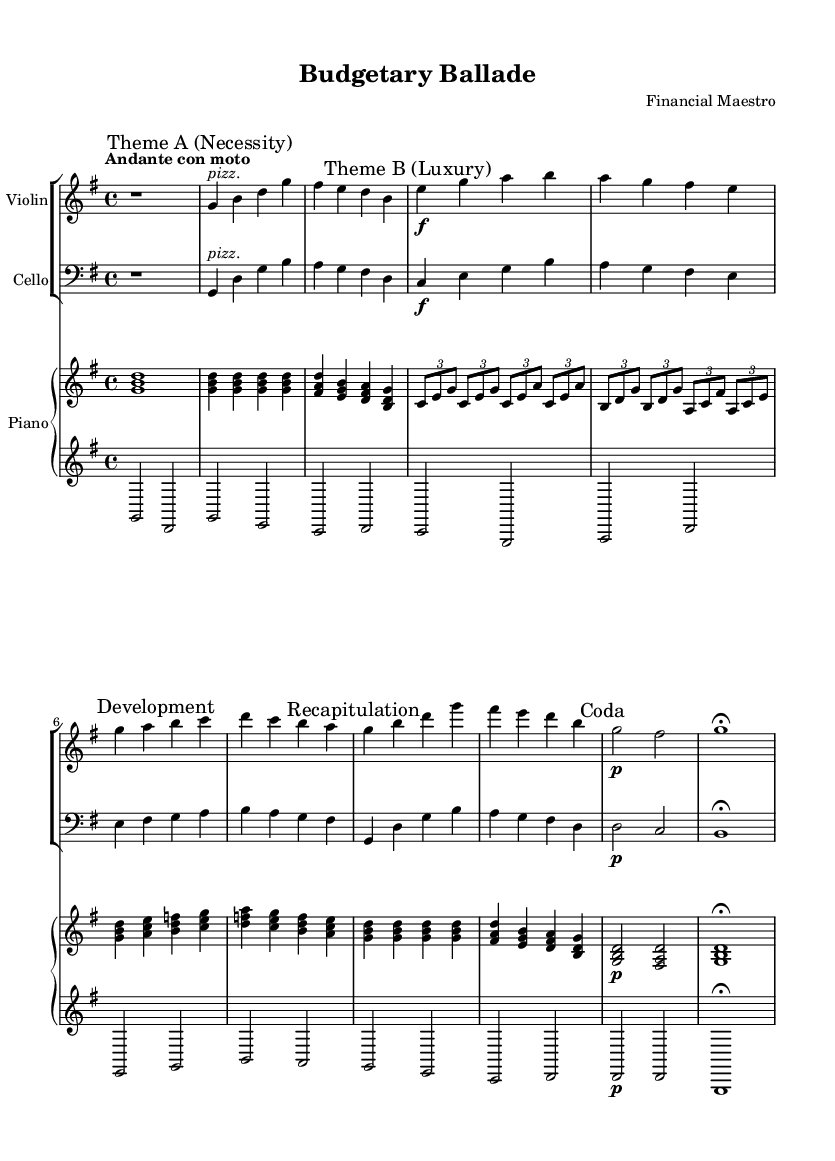What is the key signature of this music? The key signature indicates that there are no sharps or flats, which identifies it as G major.
Answer: G major What is the time signature of this music? The time signature is indicated at the beginning of the piece and shows there are four beats per measure, represented as 4/4.
Answer: 4/4 What is the tempo marking for this piece? The tempo marking is written above the staff and indicates the speed of the music, noted as "Andante con moto," which suggests a moderately slow pace with some motion.
Answer: Andante con moto Which theme represents "Necessity"? The music sheet has markings indicating different themes, with "Theme A (Necessity)" specifically labeled, showing that the first primary theme corresponds to necessity.
Answer: Theme A (Necessity) What instruments are featured in the score? The score includes a Violin, Cello, and a Piano, as indicated by the staff labels at the beginning of each part.
Answer: Violin, Cello, Piano What section follows "Theme B (Luxury)" in the structure of the music? The structure of the music is organized in a clear pattern; after "Theme B (Luxury)," the next section is labeled "Development," indicating a variance from the previously presented themes.
Answer: Development What dynamic marking is indicated at the beginning of "Theme B (Luxury)"? The sheet music specifies a dynamic indicating a loud volume, marked as "f" (forte), which shows that this section should be played strongly.
Answer: f 